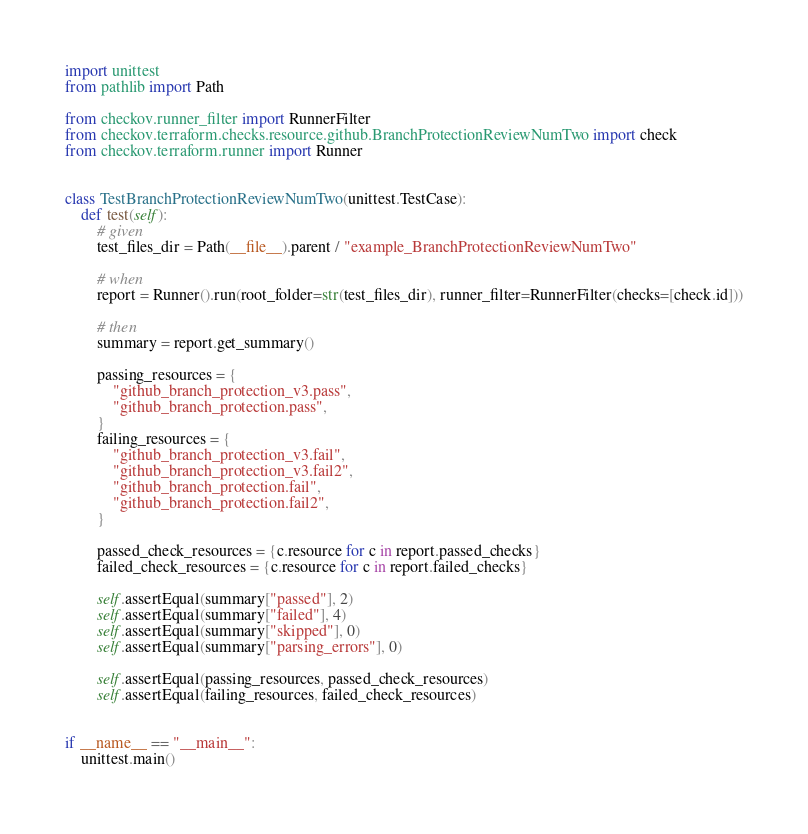<code> <loc_0><loc_0><loc_500><loc_500><_Python_>import unittest
from pathlib import Path

from checkov.runner_filter import RunnerFilter
from checkov.terraform.checks.resource.github.BranchProtectionReviewNumTwo import check
from checkov.terraform.runner import Runner


class TestBranchProtectionReviewNumTwo(unittest.TestCase):
    def test(self):
        # given
        test_files_dir = Path(__file__).parent / "example_BranchProtectionReviewNumTwo"

        # when
        report = Runner().run(root_folder=str(test_files_dir), runner_filter=RunnerFilter(checks=[check.id]))

        # then
        summary = report.get_summary()

        passing_resources = {
            "github_branch_protection_v3.pass",
            "github_branch_protection.pass",
        }
        failing_resources = {
            "github_branch_protection_v3.fail",
            "github_branch_protection_v3.fail2",
            "github_branch_protection.fail",
            "github_branch_protection.fail2",
        }

        passed_check_resources = {c.resource for c in report.passed_checks}
        failed_check_resources = {c.resource for c in report.failed_checks}

        self.assertEqual(summary["passed"], 2)
        self.assertEqual(summary["failed"], 4)
        self.assertEqual(summary["skipped"], 0)
        self.assertEqual(summary["parsing_errors"], 0)

        self.assertEqual(passing_resources, passed_check_resources)
        self.assertEqual(failing_resources, failed_check_resources)


if __name__ == "__main__":
    unittest.main()
</code> 